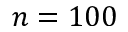Convert formula to latex. <formula><loc_0><loc_0><loc_500><loc_500>n = 1 0 0</formula> 